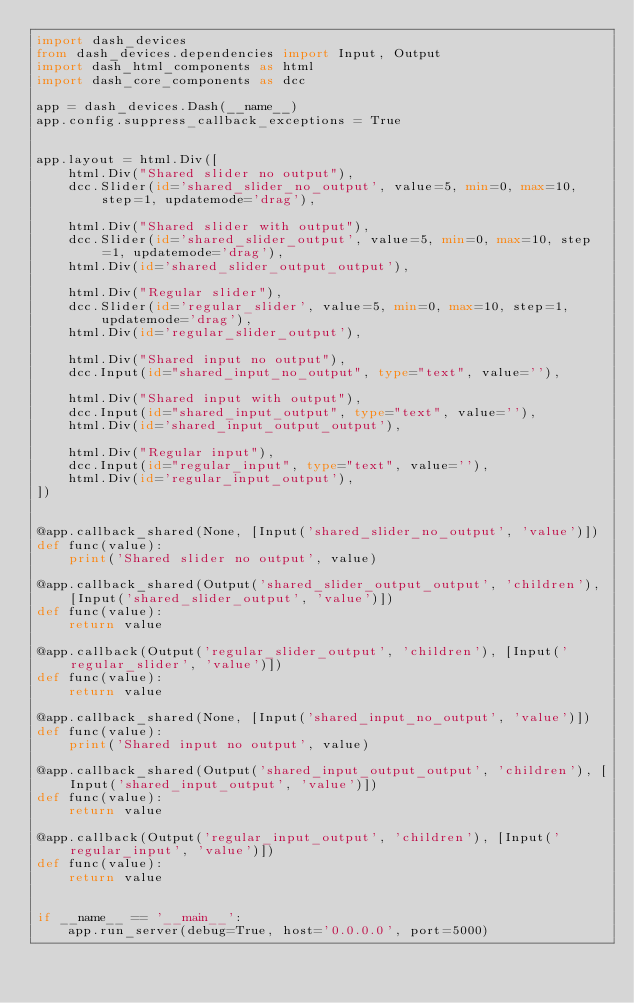Convert code to text. <code><loc_0><loc_0><loc_500><loc_500><_Python_>import dash_devices
from dash_devices.dependencies import Input, Output
import dash_html_components as html
import dash_core_components as dcc

app = dash_devices.Dash(__name__)
app.config.suppress_callback_exceptions = True


app.layout = html.Div([
    html.Div("Shared slider no output"),
    dcc.Slider(id='shared_slider_no_output', value=5, min=0, max=10, step=1, updatemode='drag'),

    html.Div("Shared slider with output"),
    dcc.Slider(id='shared_slider_output', value=5, min=0, max=10, step=1, updatemode='drag'),
    html.Div(id='shared_slider_output_output'),

    html.Div("Regular slider"),
    dcc.Slider(id='regular_slider', value=5, min=0, max=10, step=1, updatemode='drag'),
    html.Div(id='regular_slider_output'),

    html.Div("Shared input no output"),
    dcc.Input(id="shared_input_no_output", type="text", value=''), 

    html.Div("Shared input with output"),
    dcc.Input(id="shared_input_output", type="text", value=''), 
    html.Div(id='shared_input_output_output'),

    html.Div("Regular input"),
    dcc.Input(id="regular_input", type="text", value=''), 
    html.Div(id='regular_input_output'),
])


@app.callback_shared(None, [Input('shared_slider_no_output', 'value')])
def func(value):
    print('Shared slider no output', value)

@app.callback_shared(Output('shared_slider_output_output', 'children'), [Input('shared_slider_output', 'value')])
def func(value):
    return value

@app.callback(Output('regular_slider_output', 'children'), [Input('regular_slider', 'value')])
def func(value):
    return value

@app.callback_shared(None, [Input('shared_input_no_output', 'value')])
def func(value):
    print('Shared input no output', value)

@app.callback_shared(Output('shared_input_output_output', 'children'), [Input('shared_input_output', 'value')])
def func(value):
    return value

@app.callback(Output('regular_input_output', 'children'), [Input('regular_input', 'value')])
def func(value):
    return value


if __name__ == '__main__':
    app.run_server(debug=True, host='0.0.0.0', port=5000)</code> 